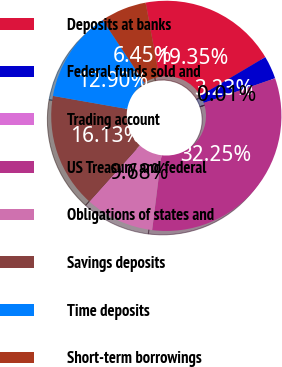Convert chart. <chart><loc_0><loc_0><loc_500><loc_500><pie_chart><fcel>Deposits at banks<fcel>Federal funds sold and<fcel>Trading account<fcel>US Treasury and federal<fcel>Obligations of states and<fcel>Savings deposits<fcel>Time deposits<fcel>Short-term borrowings<nl><fcel>19.35%<fcel>3.23%<fcel>0.01%<fcel>32.25%<fcel>9.68%<fcel>16.13%<fcel>12.9%<fcel>6.45%<nl></chart> 